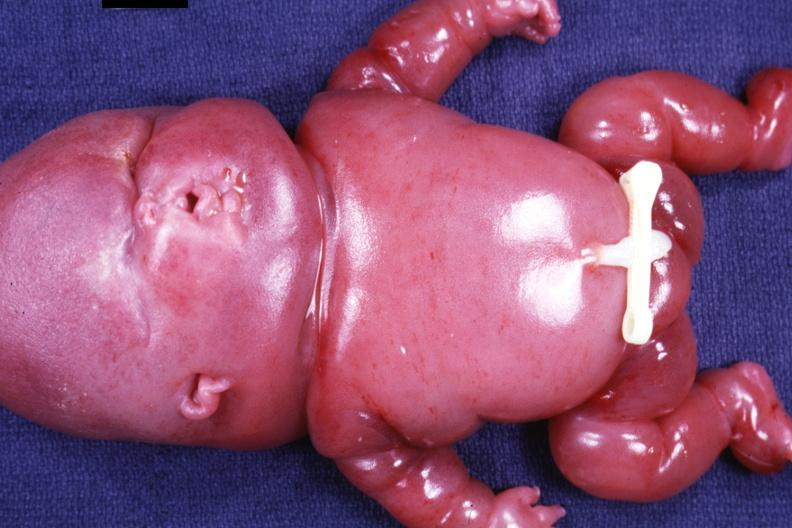what is present?
Answer the question using a single word or phrase. Lymphangiomatosis 